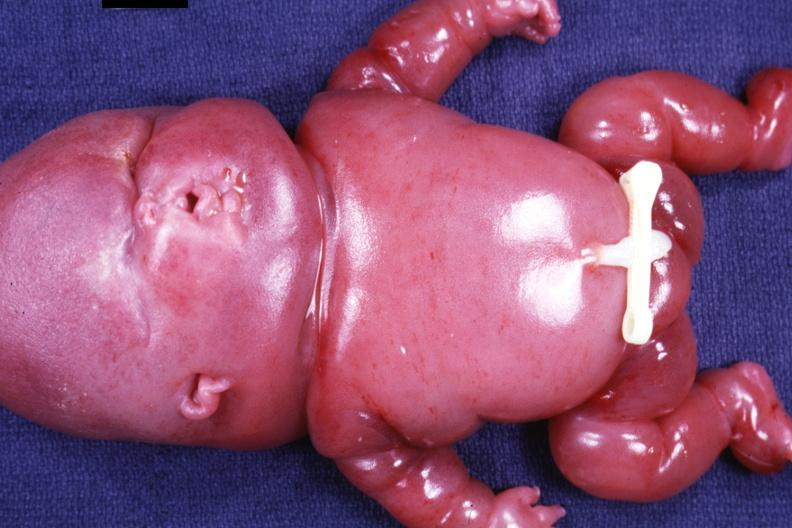what is present?
Answer the question using a single word or phrase. Lymphangiomatosis 